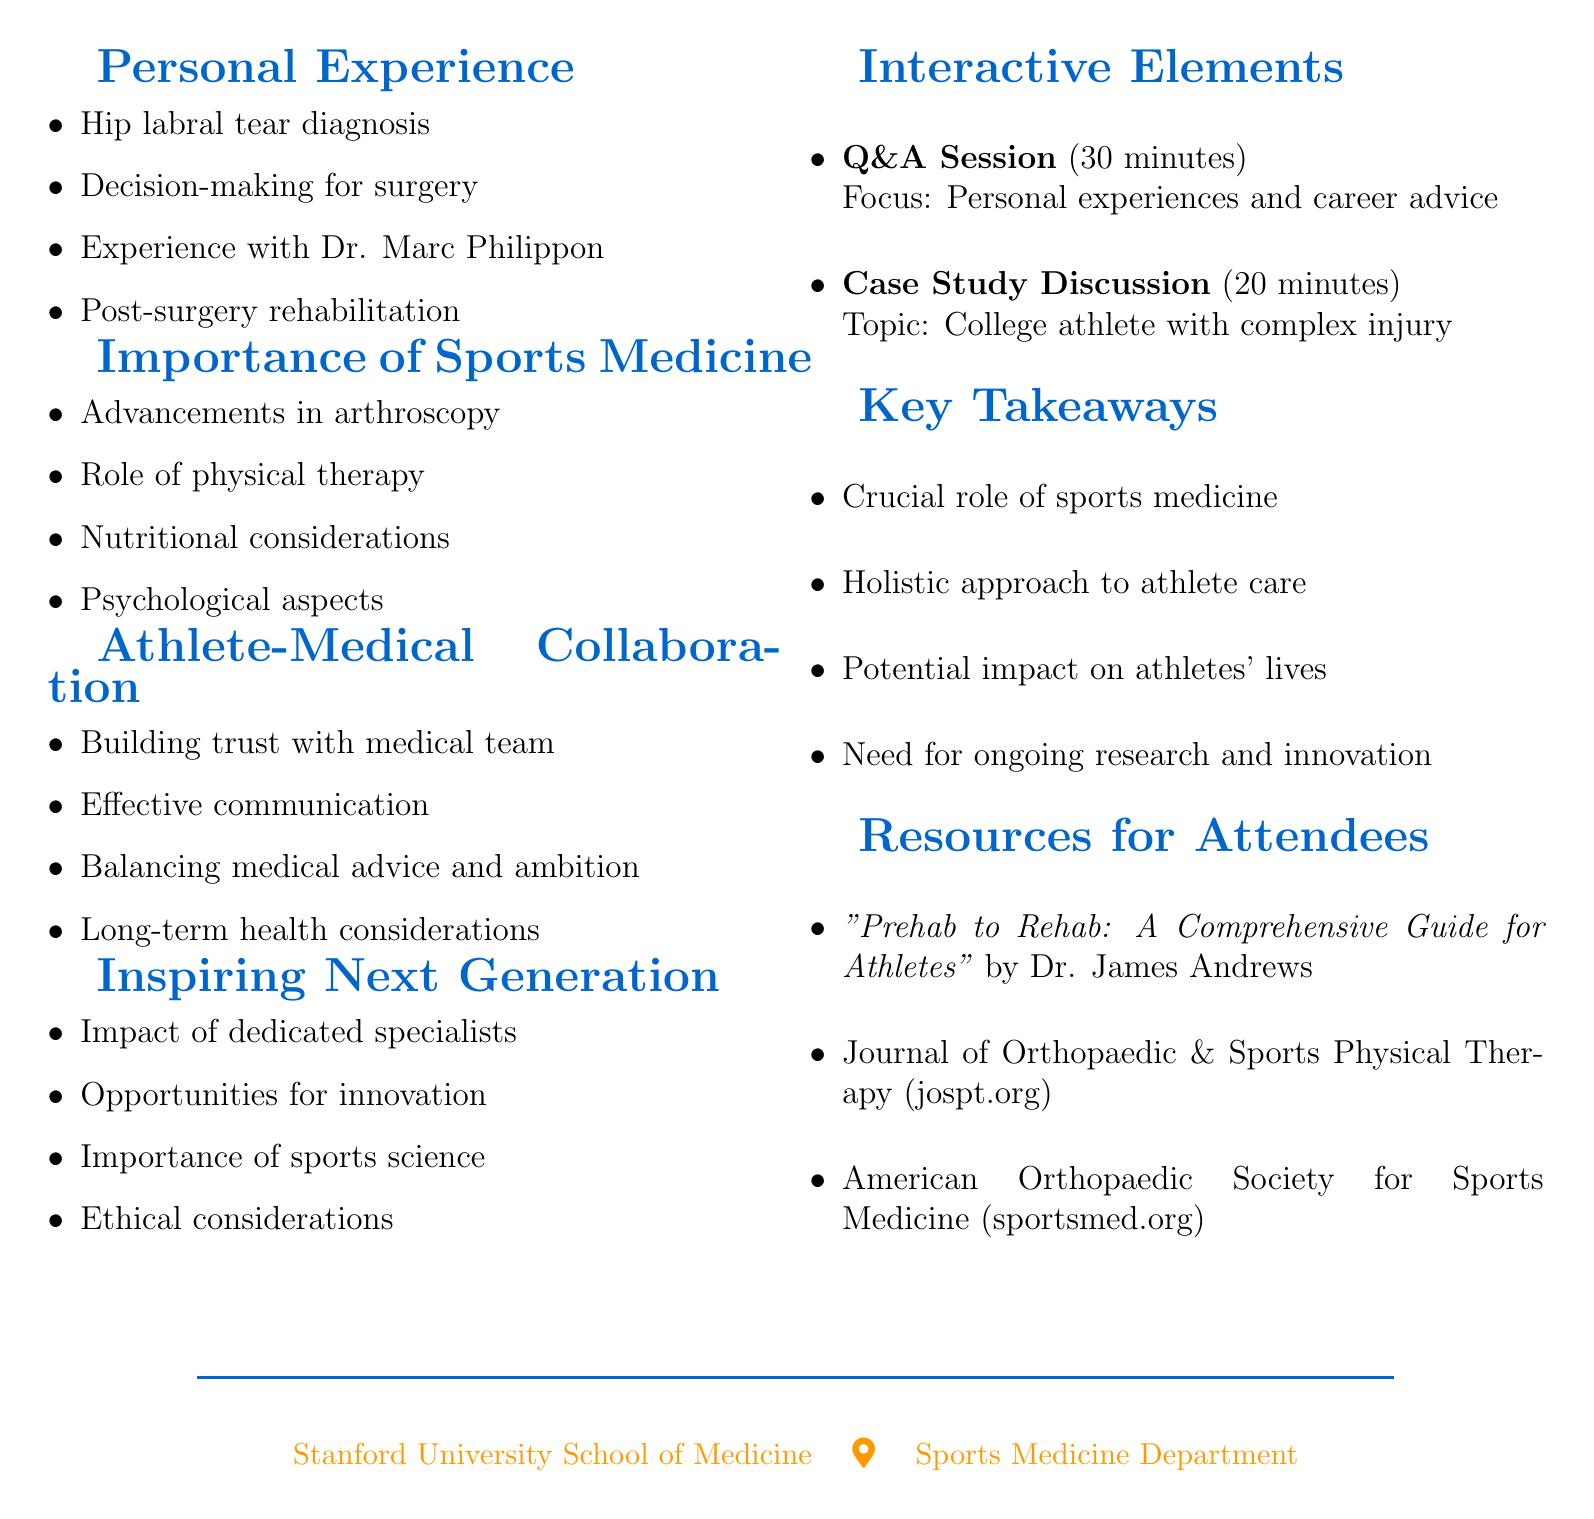What is the title of the event? The title of the event is "From Patient to Inspiration: A Journey Through Sports Medicine."
Answer: From Patient to Inspiration: A Journey Through Sports Medicine Who is the speaker of the event? The speaker of the event is mentioned as Alex Rodriguez, a former MLB player.
Answer: Alex Rodriguez What is the date of the event? The document specifies that the event will take place on October 15, 2023.
Answer: October 15, 2023 How long is the Q&A Session? The document states that the Q&A session will last for 30 minutes.
Answer: 30 minutes What is one focus of the "Athlete-Medical Collaboration" section? The document lists "Building trust with your medical team" as a focus within that section.
Answer: Building trust with your medical team Name one resource provided for attendees. One resource mentioned for attendees is a book titled "Prehab to Rehab: A Comprehensive Guide for Athletes."
Answer: "Prehab to Rehab: A Comprehensive Guide for Athletes" What is the duration of the Case Study Discussion? The document indicates that the Case Study Discussion will take 20 minutes.
Answer: 20 minutes What important role does sports medicine play according to the key takeaways? The key takeaway emphasizes the "crucial role of sports medicine in extending and improving athletic careers."
Answer: Crucial role of sports medicine in extending and improving athletic careers What organization is mentioned in the resources for attendees? The American Orthopaedic Society for Sports Medicine is mentioned in the resources.
Answer: American Orthopaedic Society for Sports Medicine 